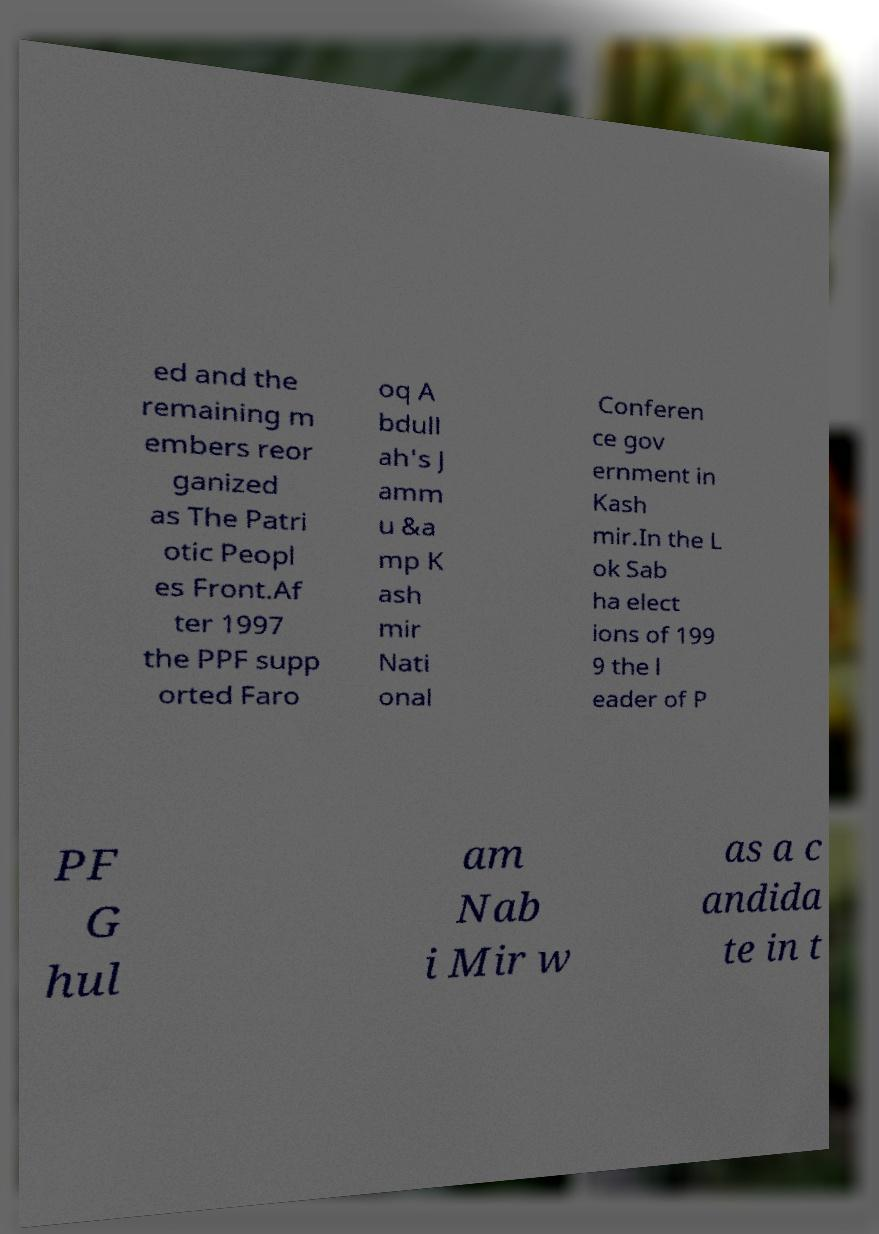Can you read and provide the text displayed in the image?This photo seems to have some interesting text. Can you extract and type it out for me? ed and the remaining m embers reor ganized as The Patri otic Peopl es Front.Af ter 1997 the PPF supp orted Faro oq A bdull ah's J amm u &a mp K ash mir Nati onal Conferen ce gov ernment in Kash mir.In the L ok Sab ha elect ions of 199 9 the l eader of P PF G hul am Nab i Mir w as a c andida te in t 